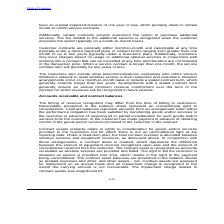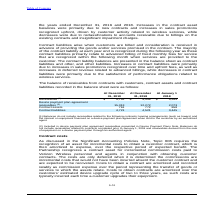According to Consolidated Communications Holdings's financial document, What is contract balances? amounts from an arrangement when either the performance obligation has been satisfied by transferring goods and/or services to the customer in advance of receiving all or partial consideration for such goods and/or services from the customer, or the customer has made payment in advance of obtaining control of the goods and/or services promised to the customer in the contract.. The document states: "ight to consideration. Contract balances represent amounts from an arrangement when either the performance obligation has been satisfied by transferri..." Also, What are contract assets related to? primarily relate to rights to consideration for goods and/or services provided to the customers but for which there is not an unconditional right at the reporting date.. The document states: "Contract assets primarily relate to rights to consideration for goods and/or services provided to the customers but for which there is not an uncondit..." Also, Where are the contract asset balances presented? The contract asset balances are presented in the balance sheets as prepaid expenses and other, and other assets - net.. The document states: "s in the right to the payment being unconditional. The contract asset balances are presented in the balance sheets as prepaid expenses and other, and ..." Also, can you calculate: What is the increase / (decrease) in the receivables from 31 December 2018 to 31 December 2019? Based on the calculation: 5,752 - 5,448, the result is 304. This is based on the information: "Receivables (1) $ 5,752 $ 5,448 $ 5,555 Receivables (1) $ 5,752 $ 5,448 $ 5,555..." The key data points involved are: 5,448, 5,752. Also, can you calculate: What is the average contract assets for years ended 2018 and 2019? To answer this question, I need to perform calculations using the financial data. The calculation is: (761 + 772) / 2, which equals 766.5. This is based on the information: "Contract assets 761 772 858 Contract assets 761 772 858..." The key data points involved are: 761, 772. Also, can you calculate: What was the increase / (decrease) in contract liabilities from December 2018 to December 2019? Based on the calculation: 4,721 - 4,521, the result is 200. This is based on the information: "Contract liabilities 4,721 4,521 3,445 Contract liabilities 4,721 4,521 3,445..." The key data points involved are: 4,521, 4,721. 